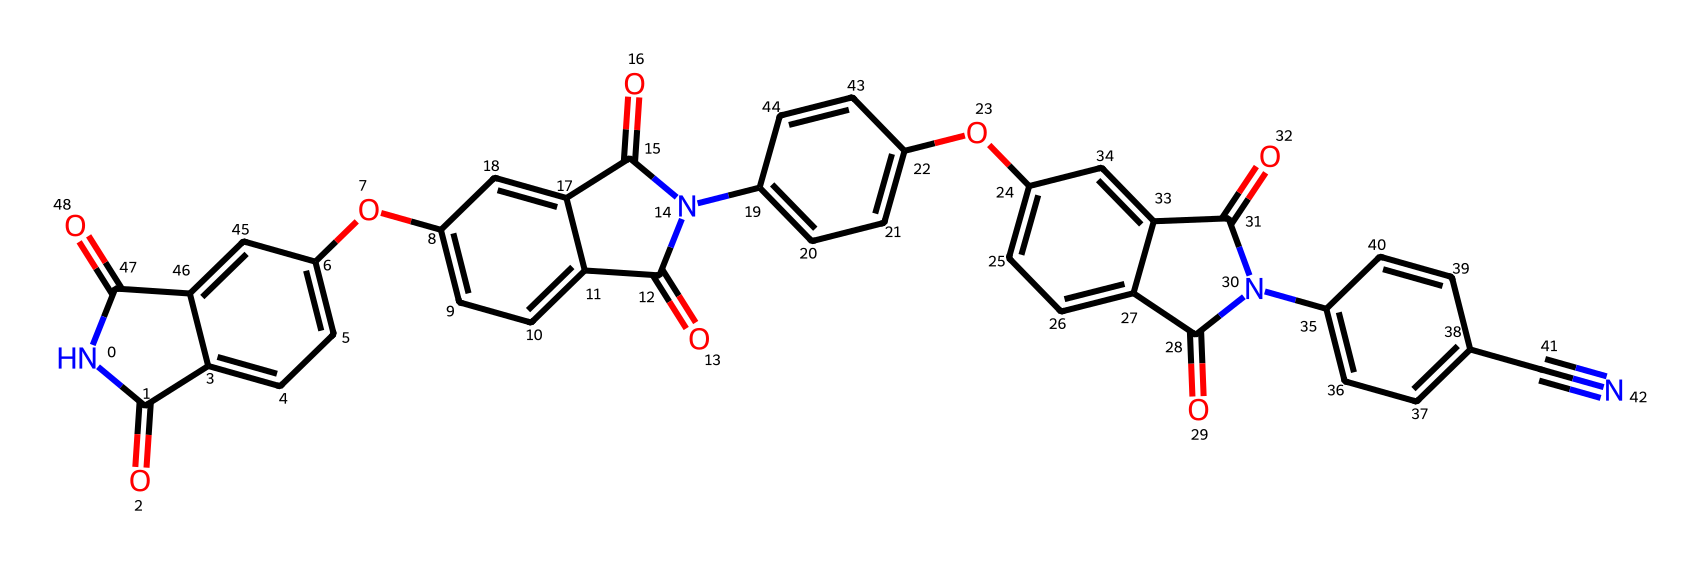What is the functional group present in this compound? The presence of the nitrogen atom (indicated by "N") and the carbonyl groups (C=O) in the structure suggests it contains amide functional groups.
Answer: amide How many distinct aromatic rings can be identified in this structure? By analyzing the structure, there are five distinct aromatic rings present, as indicated by the fused benzene-like cyclic structures.
Answer: five What is the total number of nitrogen atoms in the chemical? Looking at the molecular structure, there are two nitrogen atoms; they can be identified from the two occurrences of the letter "N" in the SMILES representation.
Answer: two How would you classify this polymer in terms of thermal resistance? Given that polyimides are known for their excellent thermal stability due to their strong imide linkages in the structure, this compound can be classified as a high-temperature resistant polymer.
Answer: high-temperature resistant What type of bonding is primarily responsible for the rigidity of this polymer? The extensive network of carbonyl (C=O) groups and the imide linkages contributes to the rigidity of the polymer, resulting in strong dipole-dipole interactions that enhance structural integrity.
Answer: dipole-dipole interactions What is the molecular weight range typical for high-temperature resistant polyimides like this one? High-temperature resistant polyimides often fall within a molecular weight range of approximately 2000-40000 g/mol, depending on their structure and the length of the polymer chains.
Answer: 2000-40000 g/mol 